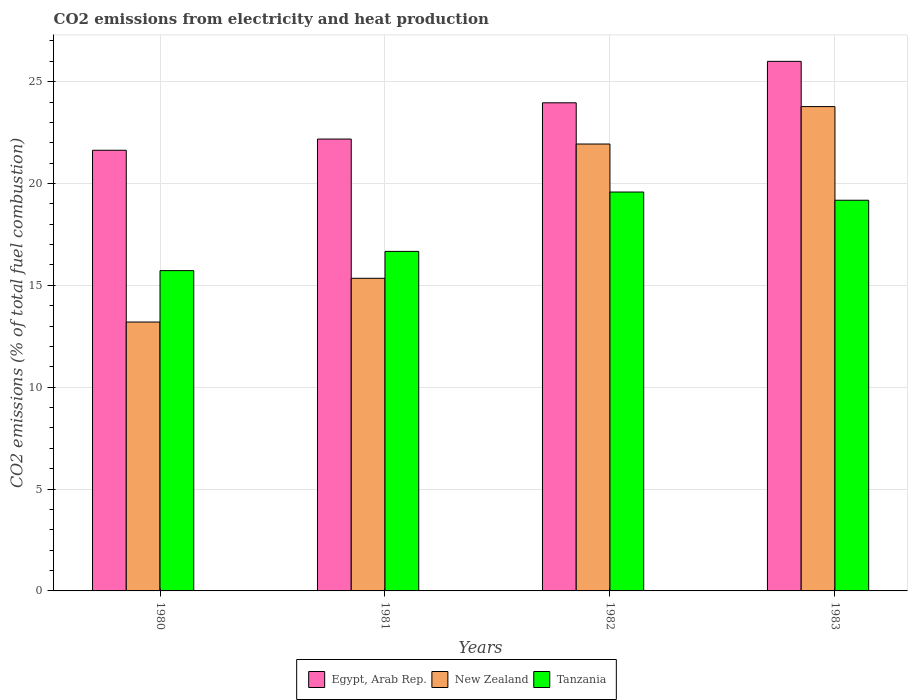Are the number of bars on each tick of the X-axis equal?
Ensure brevity in your answer.  Yes. How many bars are there on the 2nd tick from the left?
Your answer should be compact. 3. What is the label of the 1st group of bars from the left?
Provide a short and direct response. 1980. What is the amount of CO2 emitted in New Zealand in 1981?
Offer a very short reply. 15.35. Across all years, what is the maximum amount of CO2 emitted in Egypt, Arab Rep.?
Give a very brief answer. 26. Across all years, what is the minimum amount of CO2 emitted in New Zealand?
Ensure brevity in your answer.  13.2. In which year was the amount of CO2 emitted in New Zealand maximum?
Provide a short and direct response. 1983. What is the total amount of CO2 emitted in Tanzania in the graph?
Your answer should be compact. 71.15. What is the difference between the amount of CO2 emitted in Tanzania in 1980 and that in 1982?
Give a very brief answer. -3.86. What is the difference between the amount of CO2 emitted in Tanzania in 1982 and the amount of CO2 emitted in Egypt, Arab Rep. in 1980?
Provide a succinct answer. -2.05. What is the average amount of CO2 emitted in New Zealand per year?
Provide a succinct answer. 18.56. In the year 1983, what is the difference between the amount of CO2 emitted in Tanzania and amount of CO2 emitted in New Zealand?
Your answer should be compact. -4.6. What is the ratio of the amount of CO2 emitted in New Zealand in 1980 to that in 1982?
Your response must be concise. 0.6. Is the difference between the amount of CO2 emitted in Tanzania in 1981 and 1983 greater than the difference between the amount of CO2 emitted in New Zealand in 1981 and 1983?
Give a very brief answer. Yes. What is the difference between the highest and the second highest amount of CO2 emitted in New Zealand?
Ensure brevity in your answer.  1.84. What is the difference between the highest and the lowest amount of CO2 emitted in Tanzania?
Your answer should be compact. 3.86. In how many years, is the amount of CO2 emitted in Tanzania greater than the average amount of CO2 emitted in Tanzania taken over all years?
Ensure brevity in your answer.  2. What does the 3rd bar from the left in 1980 represents?
Make the answer very short. Tanzania. What does the 1st bar from the right in 1981 represents?
Your response must be concise. Tanzania. Is it the case that in every year, the sum of the amount of CO2 emitted in Egypt, Arab Rep. and amount of CO2 emitted in New Zealand is greater than the amount of CO2 emitted in Tanzania?
Keep it short and to the point. Yes. How many bars are there?
Your answer should be compact. 12. What is the difference between two consecutive major ticks on the Y-axis?
Provide a succinct answer. 5. Are the values on the major ticks of Y-axis written in scientific E-notation?
Your response must be concise. No. What is the title of the graph?
Offer a terse response. CO2 emissions from electricity and heat production. What is the label or title of the X-axis?
Make the answer very short. Years. What is the label or title of the Y-axis?
Make the answer very short. CO2 emissions (% of total fuel combustion). What is the CO2 emissions (% of total fuel combustion) in Egypt, Arab Rep. in 1980?
Provide a succinct answer. 21.63. What is the CO2 emissions (% of total fuel combustion) of New Zealand in 1980?
Provide a short and direct response. 13.2. What is the CO2 emissions (% of total fuel combustion) in Tanzania in 1980?
Your answer should be very brief. 15.72. What is the CO2 emissions (% of total fuel combustion) in Egypt, Arab Rep. in 1981?
Provide a short and direct response. 22.18. What is the CO2 emissions (% of total fuel combustion) in New Zealand in 1981?
Your answer should be very brief. 15.35. What is the CO2 emissions (% of total fuel combustion) in Tanzania in 1981?
Provide a succinct answer. 16.67. What is the CO2 emissions (% of total fuel combustion) of Egypt, Arab Rep. in 1982?
Provide a succinct answer. 23.96. What is the CO2 emissions (% of total fuel combustion) of New Zealand in 1982?
Ensure brevity in your answer.  21.94. What is the CO2 emissions (% of total fuel combustion) of Tanzania in 1982?
Your response must be concise. 19.58. What is the CO2 emissions (% of total fuel combustion) in Egypt, Arab Rep. in 1983?
Make the answer very short. 26. What is the CO2 emissions (% of total fuel combustion) in New Zealand in 1983?
Make the answer very short. 23.78. What is the CO2 emissions (% of total fuel combustion) of Tanzania in 1983?
Ensure brevity in your answer.  19.18. Across all years, what is the maximum CO2 emissions (% of total fuel combustion) in Egypt, Arab Rep.?
Your answer should be very brief. 26. Across all years, what is the maximum CO2 emissions (% of total fuel combustion) of New Zealand?
Provide a succinct answer. 23.78. Across all years, what is the maximum CO2 emissions (% of total fuel combustion) of Tanzania?
Offer a very short reply. 19.58. Across all years, what is the minimum CO2 emissions (% of total fuel combustion) in Egypt, Arab Rep.?
Give a very brief answer. 21.63. Across all years, what is the minimum CO2 emissions (% of total fuel combustion) of New Zealand?
Offer a terse response. 13.2. Across all years, what is the minimum CO2 emissions (% of total fuel combustion) of Tanzania?
Your answer should be compact. 15.72. What is the total CO2 emissions (% of total fuel combustion) in Egypt, Arab Rep. in the graph?
Your response must be concise. 93.77. What is the total CO2 emissions (% of total fuel combustion) in New Zealand in the graph?
Offer a terse response. 74.26. What is the total CO2 emissions (% of total fuel combustion) of Tanzania in the graph?
Ensure brevity in your answer.  71.15. What is the difference between the CO2 emissions (% of total fuel combustion) of Egypt, Arab Rep. in 1980 and that in 1981?
Your response must be concise. -0.55. What is the difference between the CO2 emissions (% of total fuel combustion) of New Zealand in 1980 and that in 1981?
Give a very brief answer. -2.15. What is the difference between the CO2 emissions (% of total fuel combustion) of Tanzania in 1980 and that in 1981?
Your response must be concise. -0.94. What is the difference between the CO2 emissions (% of total fuel combustion) of Egypt, Arab Rep. in 1980 and that in 1982?
Give a very brief answer. -2.33. What is the difference between the CO2 emissions (% of total fuel combustion) of New Zealand in 1980 and that in 1982?
Give a very brief answer. -8.74. What is the difference between the CO2 emissions (% of total fuel combustion) in Tanzania in 1980 and that in 1982?
Give a very brief answer. -3.86. What is the difference between the CO2 emissions (% of total fuel combustion) of Egypt, Arab Rep. in 1980 and that in 1983?
Make the answer very short. -4.36. What is the difference between the CO2 emissions (% of total fuel combustion) of New Zealand in 1980 and that in 1983?
Provide a short and direct response. -10.58. What is the difference between the CO2 emissions (% of total fuel combustion) of Tanzania in 1980 and that in 1983?
Keep it short and to the point. -3.45. What is the difference between the CO2 emissions (% of total fuel combustion) in Egypt, Arab Rep. in 1981 and that in 1982?
Offer a very short reply. -1.78. What is the difference between the CO2 emissions (% of total fuel combustion) of New Zealand in 1981 and that in 1982?
Give a very brief answer. -6.59. What is the difference between the CO2 emissions (% of total fuel combustion) of Tanzania in 1981 and that in 1982?
Make the answer very short. -2.91. What is the difference between the CO2 emissions (% of total fuel combustion) in Egypt, Arab Rep. in 1981 and that in 1983?
Keep it short and to the point. -3.81. What is the difference between the CO2 emissions (% of total fuel combustion) in New Zealand in 1981 and that in 1983?
Your answer should be very brief. -8.43. What is the difference between the CO2 emissions (% of total fuel combustion) in Tanzania in 1981 and that in 1983?
Your answer should be very brief. -2.51. What is the difference between the CO2 emissions (% of total fuel combustion) in Egypt, Arab Rep. in 1982 and that in 1983?
Ensure brevity in your answer.  -2.03. What is the difference between the CO2 emissions (% of total fuel combustion) of New Zealand in 1982 and that in 1983?
Your answer should be compact. -1.84. What is the difference between the CO2 emissions (% of total fuel combustion) of Tanzania in 1982 and that in 1983?
Your response must be concise. 0.4. What is the difference between the CO2 emissions (% of total fuel combustion) in Egypt, Arab Rep. in 1980 and the CO2 emissions (% of total fuel combustion) in New Zealand in 1981?
Offer a terse response. 6.29. What is the difference between the CO2 emissions (% of total fuel combustion) of Egypt, Arab Rep. in 1980 and the CO2 emissions (% of total fuel combustion) of Tanzania in 1981?
Keep it short and to the point. 4.97. What is the difference between the CO2 emissions (% of total fuel combustion) of New Zealand in 1980 and the CO2 emissions (% of total fuel combustion) of Tanzania in 1981?
Offer a terse response. -3.47. What is the difference between the CO2 emissions (% of total fuel combustion) in Egypt, Arab Rep. in 1980 and the CO2 emissions (% of total fuel combustion) in New Zealand in 1982?
Offer a very short reply. -0.31. What is the difference between the CO2 emissions (% of total fuel combustion) of Egypt, Arab Rep. in 1980 and the CO2 emissions (% of total fuel combustion) of Tanzania in 1982?
Keep it short and to the point. 2.05. What is the difference between the CO2 emissions (% of total fuel combustion) of New Zealand in 1980 and the CO2 emissions (% of total fuel combustion) of Tanzania in 1982?
Provide a succinct answer. -6.38. What is the difference between the CO2 emissions (% of total fuel combustion) in Egypt, Arab Rep. in 1980 and the CO2 emissions (% of total fuel combustion) in New Zealand in 1983?
Make the answer very short. -2.14. What is the difference between the CO2 emissions (% of total fuel combustion) of Egypt, Arab Rep. in 1980 and the CO2 emissions (% of total fuel combustion) of Tanzania in 1983?
Your answer should be very brief. 2.45. What is the difference between the CO2 emissions (% of total fuel combustion) in New Zealand in 1980 and the CO2 emissions (% of total fuel combustion) in Tanzania in 1983?
Your response must be concise. -5.98. What is the difference between the CO2 emissions (% of total fuel combustion) of Egypt, Arab Rep. in 1981 and the CO2 emissions (% of total fuel combustion) of New Zealand in 1982?
Keep it short and to the point. 0.24. What is the difference between the CO2 emissions (% of total fuel combustion) in Egypt, Arab Rep. in 1981 and the CO2 emissions (% of total fuel combustion) in Tanzania in 1982?
Your answer should be very brief. 2.6. What is the difference between the CO2 emissions (% of total fuel combustion) of New Zealand in 1981 and the CO2 emissions (% of total fuel combustion) of Tanzania in 1982?
Keep it short and to the point. -4.23. What is the difference between the CO2 emissions (% of total fuel combustion) of Egypt, Arab Rep. in 1981 and the CO2 emissions (% of total fuel combustion) of New Zealand in 1983?
Your answer should be compact. -1.59. What is the difference between the CO2 emissions (% of total fuel combustion) of Egypt, Arab Rep. in 1981 and the CO2 emissions (% of total fuel combustion) of Tanzania in 1983?
Make the answer very short. 3. What is the difference between the CO2 emissions (% of total fuel combustion) in New Zealand in 1981 and the CO2 emissions (% of total fuel combustion) in Tanzania in 1983?
Provide a succinct answer. -3.83. What is the difference between the CO2 emissions (% of total fuel combustion) of Egypt, Arab Rep. in 1982 and the CO2 emissions (% of total fuel combustion) of New Zealand in 1983?
Provide a succinct answer. 0.19. What is the difference between the CO2 emissions (% of total fuel combustion) of Egypt, Arab Rep. in 1982 and the CO2 emissions (% of total fuel combustion) of Tanzania in 1983?
Give a very brief answer. 4.78. What is the difference between the CO2 emissions (% of total fuel combustion) of New Zealand in 1982 and the CO2 emissions (% of total fuel combustion) of Tanzania in 1983?
Keep it short and to the point. 2.76. What is the average CO2 emissions (% of total fuel combustion) in Egypt, Arab Rep. per year?
Your answer should be compact. 23.44. What is the average CO2 emissions (% of total fuel combustion) in New Zealand per year?
Provide a succinct answer. 18.56. What is the average CO2 emissions (% of total fuel combustion) in Tanzania per year?
Provide a succinct answer. 17.79. In the year 1980, what is the difference between the CO2 emissions (% of total fuel combustion) of Egypt, Arab Rep. and CO2 emissions (% of total fuel combustion) of New Zealand?
Your answer should be compact. 8.43. In the year 1980, what is the difference between the CO2 emissions (% of total fuel combustion) of Egypt, Arab Rep. and CO2 emissions (% of total fuel combustion) of Tanzania?
Ensure brevity in your answer.  5.91. In the year 1980, what is the difference between the CO2 emissions (% of total fuel combustion) of New Zealand and CO2 emissions (% of total fuel combustion) of Tanzania?
Your answer should be very brief. -2.52. In the year 1981, what is the difference between the CO2 emissions (% of total fuel combustion) of Egypt, Arab Rep. and CO2 emissions (% of total fuel combustion) of New Zealand?
Keep it short and to the point. 6.83. In the year 1981, what is the difference between the CO2 emissions (% of total fuel combustion) in Egypt, Arab Rep. and CO2 emissions (% of total fuel combustion) in Tanzania?
Offer a very short reply. 5.51. In the year 1981, what is the difference between the CO2 emissions (% of total fuel combustion) in New Zealand and CO2 emissions (% of total fuel combustion) in Tanzania?
Give a very brief answer. -1.32. In the year 1982, what is the difference between the CO2 emissions (% of total fuel combustion) of Egypt, Arab Rep. and CO2 emissions (% of total fuel combustion) of New Zealand?
Keep it short and to the point. 2.02. In the year 1982, what is the difference between the CO2 emissions (% of total fuel combustion) in Egypt, Arab Rep. and CO2 emissions (% of total fuel combustion) in Tanzania?
Offer a very short reply. 4.38. In the year 1982, what is the difference between the CO2 emissions (% of total fuel combustion) in New Zealand and CO2 emissions (% of total fuel combustion) in Tanzania?
Make the answer very short. 2.36. In the year 1983, what is the difference between the CO2 emissions (% of total fuel combustion) of Egypt, Arab Rep. and CO2 emissions (% of total fuel combustion) of New Zealand?
Your answer should be compact. 2.22. In the year 1983, what is the difference between the CO2 emissions (% of total fuel combustion) of Egypt, Arab Rep. and CO2 emissions (% of total fuel combustion) of Tanzania?
Provide a short and direct response. 6.82. In the year 1983, what is the difference between the CO2 emissions (% of total fuel combustion) of New Zealand and CO2 emissions (% of total fuel combustion) of Tanzania?
Keep it short and to the point. 4.6. What is the ratio of the CO2 emissions (% of total fuel combustion) in Egypt, Arab Rep. in 1980 to that in 1981?
Offer a very short reply. 0.98. What is the ratio of the CO2 emissions (% of total fuel combustion) of New Zealand in 1980 to that in 1981?
Make the answer very short. 0.86. What is the ratio of the CO2 emissions (% of total fuel combustion) of Tanzania in 1980 to that in 1981?
Offer a very short reply. 0.94. What is the ratio of the CO2 emissions (% of total fuel combustion) of Egypt, Arab Rep. in 1980 to that in 1982?
Offer a very short reply. 0.9. What is the ratio of the CO2 emissions (% of total fuel combustion) in New Zealand in 1980 to that in 1982?
Provide a succinct answer. 0.6. What is the ratio of the CO2 emissions (% of total fuel combustion) in Tanzania in 1980 to that in 1982?
Offer a very short reply. 0.8. What is the ratio of the CO2 emissions (% of total fuel combustion) in Egypt, Arab Rep. in 1980 to that in 1983?
Provide a succinct answer. 0.83. What is the ratio of the CO2 emissions (% of total fuel combustion) of New Zealand in 1980 to that in 1983?
Keep it short and to the point. 0.56. What is the ratio of the CO2 emissions (% of total fuel combustion) in Tanzania in 1980 to that in 1983?
Keep it short and to the point. 0.82. What is the ratio of the CO2 emissions (% of total fuel combustion) in Egypt, Arab Rep. in 1981 to that in 1982?
Offer a very short reply. 0.93. What is the ratio of the CO2 emissions (% of total fuel combustion) of New Zealand in 1981 to that in 1982?
Give a very brief answer. 0.7. What is the ratio of the CO2 emissions (% of total fuel combustion) of Tanzania in 1981 to that in 1982?
Make the answer very short. 0.85. What is the ratio of the CO2 emissions (% of total fuel combustion) in Egypt, Arab Rep. in 1981 to that in 1983?
Give a very brief answer. 0.85. What is the ratio of the CO2 emissions (% of total fuel combustion) in New Zealand in 1981 to that in 1983?
Offer a terse response. 0.65. What is the ratio of the CO2 emissions (% of total fuel combustion) in Tanzania in 1981 to that in 1983?
Keep it short and to the point. 0.87. What is the ratio of the CO2 emissions (% of total fuel combustion) in Egypt, Arab Rep. in 1982 to that in 1983?
Ensure brevity in your answer.  0.92. What is the ratio of the CO2 emissions (% of total fuel combustion) of New Zealand in 1982 to that in 1983?
Your answer should be compact. 0.92. What is the difference between the highest and the second highest CO2 emissions (% of total fuel combustion) of Egypt, Arab Rep.?
Your answer should be compact. 2.03. What is the difference between the highest and the second highest CO2 emissions (% of total fuel combustion) of New Zealand?
Your answer should be very brief. 1.84. What is the difference between the highest and the second highest CO2 emissions (% of total fuel combustion) in Tanzania?
Make the answer very short. 0.4. What is the difference between the highest and the lowest CO2 emissions (% of total fuel combustion) in Egypt, Arab Rep.?
Give a very brief answer. 4.36. What is the difference between the highest and the lowest CO2 emissions (% of total fuel combustion) of New Zealand?
Make the answer very short. 10.58. What is the difference between the highest and the lowest CO2 emissions (% of total fuel combustion) of Tanzania?
Give a very brief answer. 3.86. 